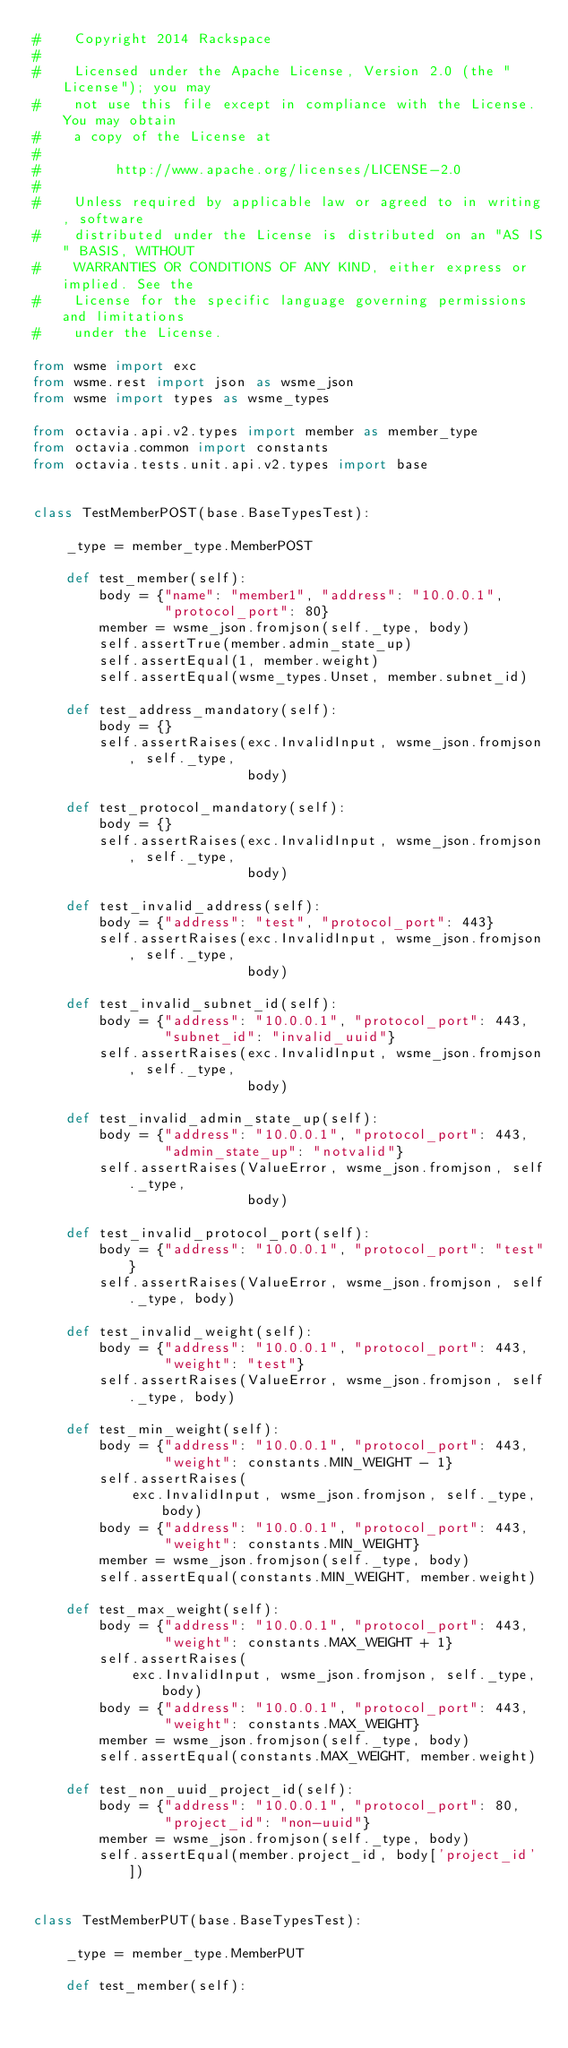Convert code to text. <code><loc_0><loc_0><loc_500><loc_500><_Python_>#    Copyright 2014 Rackspace
#
#    Licensed under the Apache License, Version 2.0 (the "License"); you may
#    not use this file except in compliance with the License. You may obtain
#    a copy of the License at
#
#         http://www.apache.org/licenses/LICENSE-2.0
#
#    Unless required by applicable law or agreed to in writing, software
#    distributed under the License is distributed on an "AS IS" BASIS, WITHOUT
#    WARRANTIES OR CONDITIONS OF ANY KIND, either express or implied. See the
#    License for the specific language governing permissions and limitations
#    under the License.

from wsme import exc
from wsme.rest import json as wsme_json
from wsme import types as wsme_types

from octavia.api.v2.types import member as member_type
from octavia.common import constants
from octavia.tests.unit.api.v2.types import base


class TestMemberPOST(base.BaseTypesTest):

    _type = member_type.MemberPOST

    def test_member(self):
        body = {"name": "member1", "address": "10.0.0.1",
                "protocol_port": 80}
        member = wsme_json.fromjson(self._type, body)
        self.assertTrue(member.admin_state_up)
        self.assertEqual(1, member.weight)
        self.assertEqual(wsme_types.Unset, member.subnet_id)

    def test_address_mandatory(self):
        body = {}
        self.assertRaises(exc.InvalidInput, wsme_json.fromjson, self._type,
                          body)

    def test_protocol_mandatory(self):
        body = {}
        self.assertRaises(exc.InvalidInput, wsme_json.fromjson, self._type,
                          body)

    def test_invalid_address(self):
        body = {"address": "test", "protocol_port": 443}
        self.assertRaises(exc.InvalidInput, wsme_json.fromjson, self._type,
                          body)

    def test_invalid_subnet_id(self):
        body = {"address": "10.0.0.1", "protocol_port": 443,
                "subnet_id": "invalid_uuid"}
        self.assertRaises(exc.InvalidInput, wsme_json.fromjson, self._type,
                          body)

    def test_invalid_admin_state_up(self):
        body = {"address": "10.0.0.1", "protocol_port": 443,
                "admin_state_up": "notvalid"}
        self.assertRaises(ValueError, wsme_json.fromjson, self._type,
                          body)

    def test_invalid_protocol_port(self):
        body = {"address": "10.0.0.1", "protocol_port": "test"}
        self.assertRaises(ValueError, wsme_json.fromjson, self._type, body)

    def test_invalid_weight(self):
        body = {"address": "10.0.0.1", "protocol_port": 443,
                "weight": "test"}
        self.assertRaises(ValueError, wsme_json.fromjson, self._type, body)

    def test_min_weight(self):
        body = {"address": "10.0.0.1", "protocol_port": 443,
                "weight": constants.MIN_WEIGHT - 1}
        self.assertRaises(
            exc.InvalidInput, wsme_json.fromjson, self._type, body)
        body = {"address": "10.0.0.1", "protocol_port": 443,
                "weight": constants.MIN_WEIGHT}
        member = wsme_json.fromjson(self._type, body)
        self.assertEqual(constants.MIN_WEIGHT, member.weight)

    def test_max_weight(self):
        body = {"address": "10.0.0.1", "protocol_port": 443,
                "weight": constants.MAX_WEIGHT + 1}
        self.assertRaises(
            exc.InvalidInput, wsme_json.fromjson, self._type, body)
        body = {"address": "10.0.0.1", "protocol_port": 443,
                "weight": constants.MAX_WEIGHT}
        member = wsme_json.fromjson(self._type, body)
        self.assertEqual(constants.MAX_WEIGHT, member.weight)

    def test_non_uuid_project_id(self):
        body = {"address": "10.0.0.1", "protocol_port": 80,
                "project_id": "non-uuid"}
        member = wsme_json.fromjson(self._type, body)
        self.assertEqual(member.project_id, body['project_id'])


class TestMemberPUT(base.BaseTypesTest):

    _type = member_type.MemberPUT

    def test_member(self):</code> 